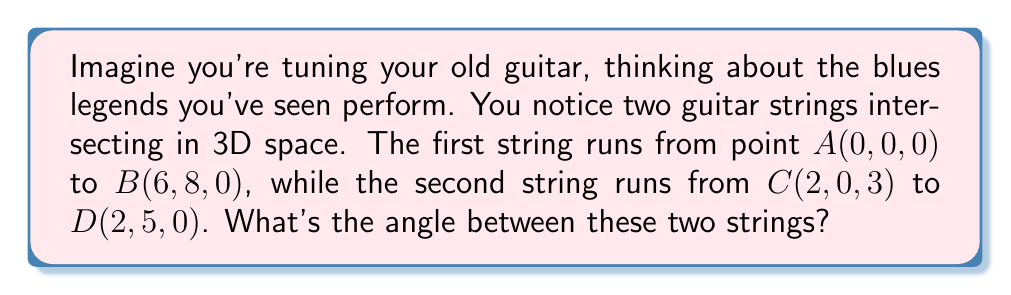Solve this math problem. Let's approach this step-by-step:

1) First, we need to find the direction vectors of both strings:

   $\vec{v_1} = \overrightarrow{AB} = (6-0, 8-0, 0-0) = (6, 8, 0)$
   $\vec{v_2} = \overrightarrow{CD} = (2-2, 5-0, 0-3) = (0, 5, -3)$

2) The angle between two vectors can be found using the dot product formula:

   $$\cos \theta = \frac{\vec{v_1} \cdot \vec{v_2}}{|\vec{v_1}||\vec{v_2}|}$$

3) Let's calculate the dot product $\vec{v_1} \cdot \vec{v_2}$:

   $\vec{v_1} \cdot \vec{v_2} = 6(0) + 8(5) + 0(-3) = 40$

4) Now, let's calculate the magnitudes:

   $|\vec{v_1}| = \sqrt{6^2 + 8^2 + 0^2} = \sqrt{100} = 10$
   $|\vec{v_2}| = \sqrt{0^2 + 5^2 + (-3)^2} = \sqrt{34}$

5) Substituting into the formula:

   $$\cos \theta = \frac{40}{10\sqrt{34}}$$

6) To find $\theta$, we take the inverse cosine (arccos) of both sides:

   $$\theta = \arccos(\frac{40}{10\sqrt{34}})$$

7) Using a calculator, we can evaluate this:

   $\theta \approx 0.9553$ radians or $54.74$ degrees
Answer: $\arccos(\frac{40}{10\sqrt{34}}) \approx 54.74°$ 